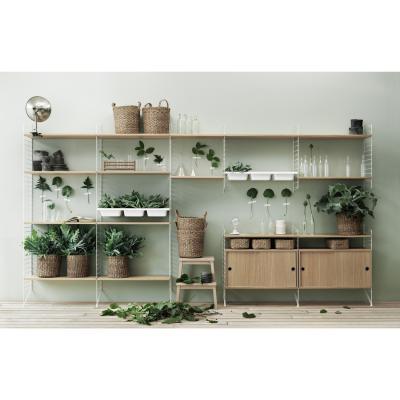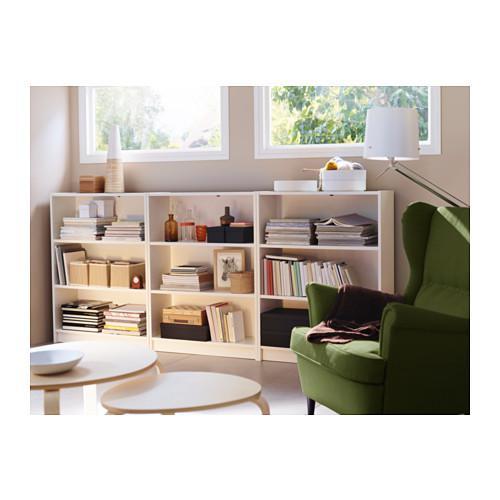The first image is the image on the left, the second image is the image on the right. Assess this claim about the two images: "One of the shelves is six rows tall.". Correct or not? Answer yes or no. No. The first image is the image on the left, the second image is the image on the right. Assess this claim about the two images: "A potted plant stands to the left of a bookshelf in each image.". Correct or not? Answer yes or no. No. 